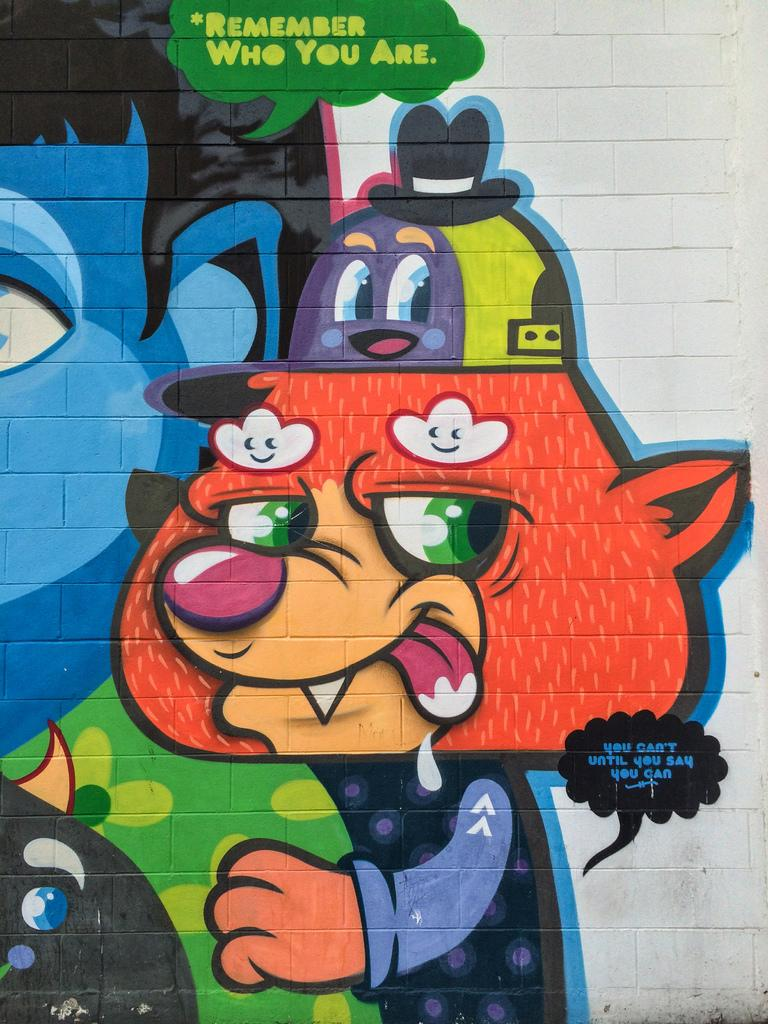What is depicted on the wall in the image? The wall has a colorful wall painting of cartoons. What is the color of the wall? The wall is white in color. What type of jewel can be seen in the wall painting? There is no jewel present in the wall painting; it features cartoons. What experience can be gained from observing the wall painting? The wall painting is a visual representation of cartoons and does not provide an experience to be gained from observing it. 